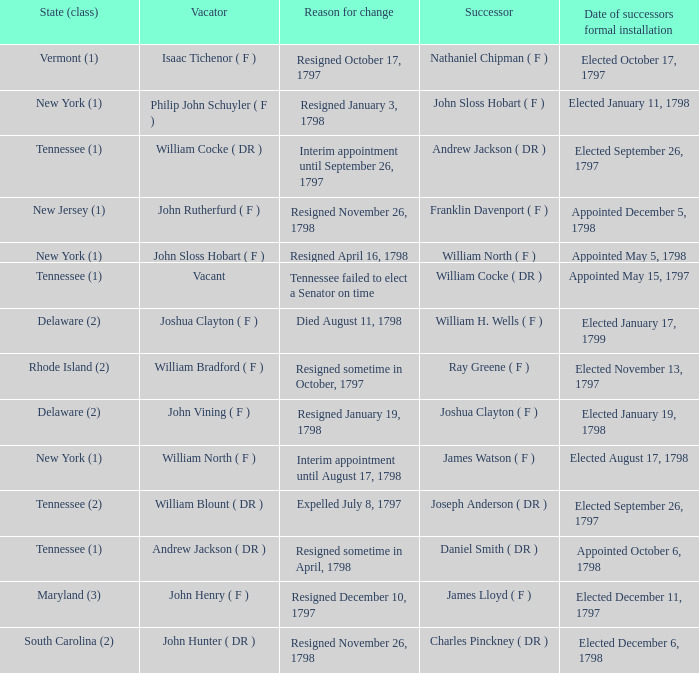What is the total number of dates of successor formal installation when the vacator was Joshua Clayton ( F )? 1.0. 